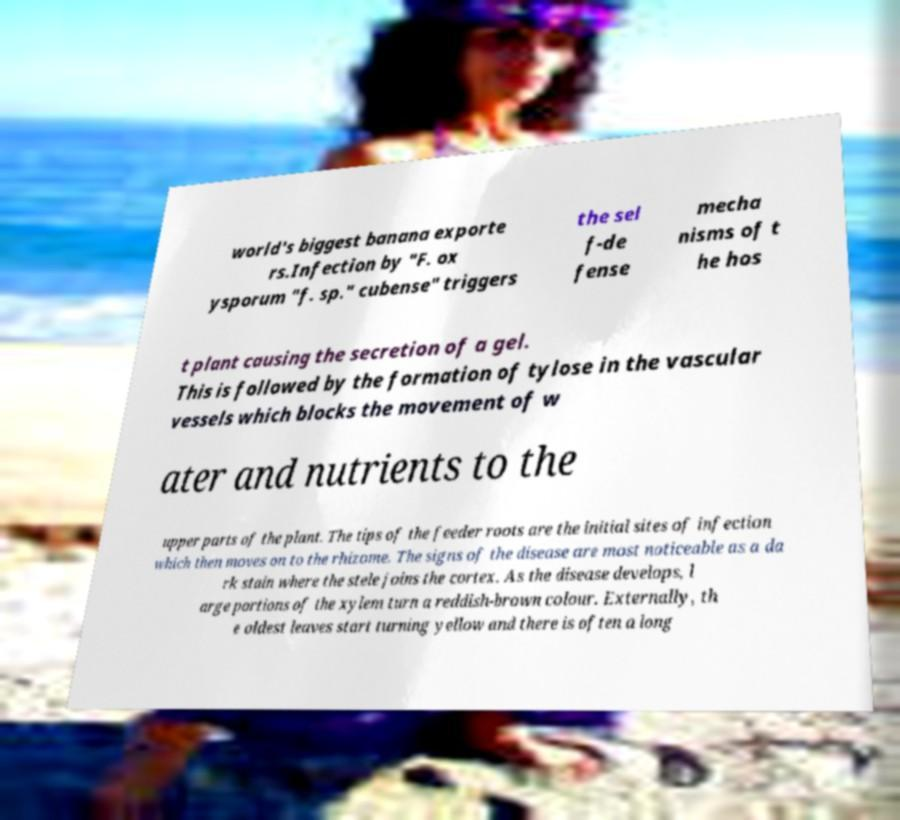What messages or text are displayed in this image? I need them in a readable, typed format. world's biggest banana exporte rs.Infection by "F. ox ysporum "f. sp." cubense" triggers the sel f-de fense mecha nisms of t he hos t plant causing the secretion of a gel. This is followed by the formation of tylose in the vascular vessels which blocks the movement of w ater and nutrients to the upper parts of the plant. The tips of the feeder roots are the initial sites of infection which then moves on to the rhizome. The signs of the disease are most noticeable as a da rk stain where the stele joins the cortex. As the disease develops, l arge portions of the xylem turn a reddish-brown colour. Externally, th e oldest leaves start turning yellow and there is often a long 